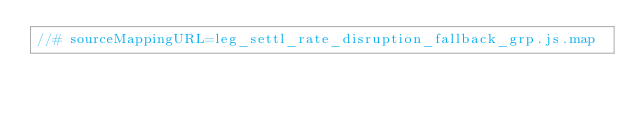<code> <loc_0><loc_0><loc_500><loc_500><_JavaScript_>//# sourceMappingURL=leg_settl_rate_disruption_fallback_grp.js.map</code> 